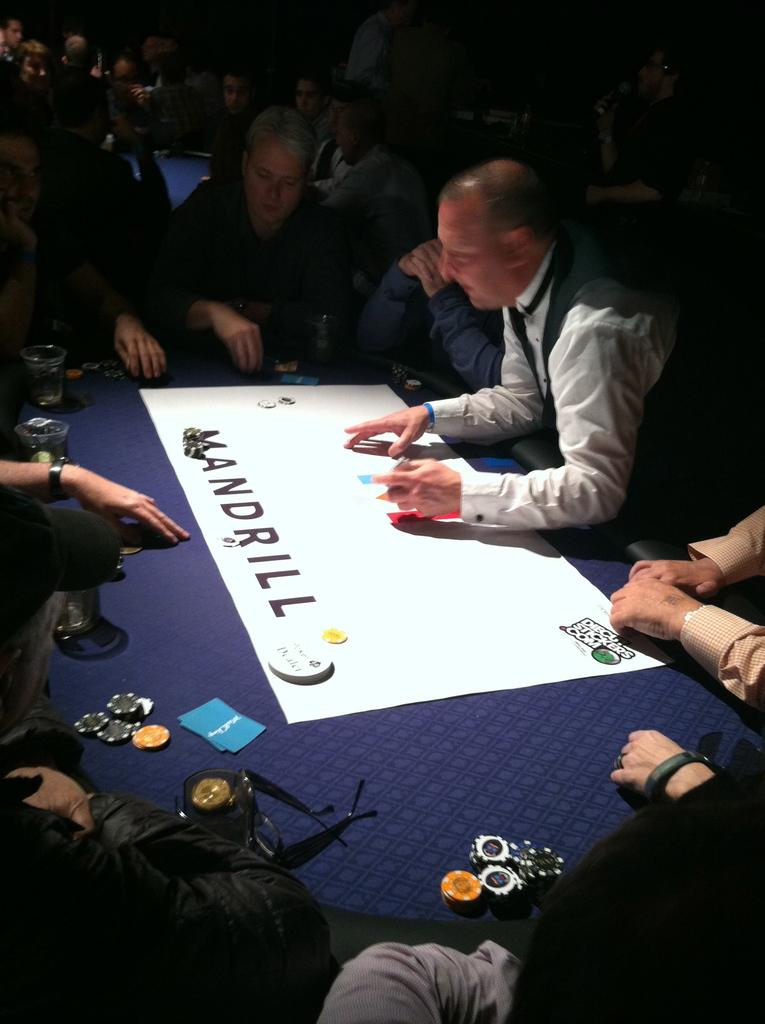What are the people in the image doing? The people in the image are sitting. What is in the center of the image? There is a table in the center of the image. What is on the table? There is a paper, glasses, specs, and a card on the table. What type of establishment can be seen in the image? There are casinos in the image. Can you see any toes sticking out from under the table in the image? There is no indication of toes or any body parts under the table in the image. What type of spring is visible on the table in the image? There is no spring present on the table in the image. 